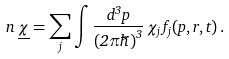<formula> <loc_0><loc_0><loc_500><loc_500>n \, \underline { \chi } = \sum _ { j } \int \frac { d ^ { 3 } p } { ( 2 \pi \hbar { ) } ^ { 3 } } \, \chi _ { j } \, f _ { j } ( { p } , { r } , t ) \, .</formula> 